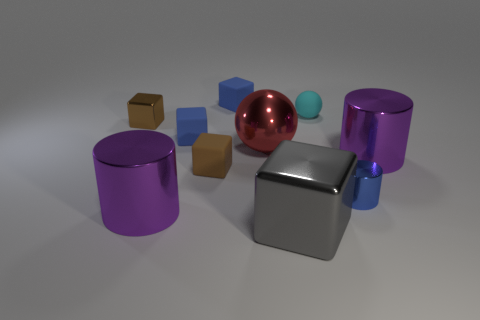Subtract 1 cylinders. How many cylinders are left? 2 Subtract all brown blocks. How many blocks are left? 3 Subtract all small metallic cubes. How many cubes are left? 4 Subtract all cyan blocks. Subtract all yellow balls. How many blocks are left? 5 Subtract 0 blue balls. How many objects are left? 10 Subtract all spheres. How many objects are left? 8 Subtract all small green things. Subtract all small spheres. How many objects are left? 9 Add 7 spheres. How many spheres are left? 9 Add 1 brown matte cubes. How many brown matte cubes exist? 2 